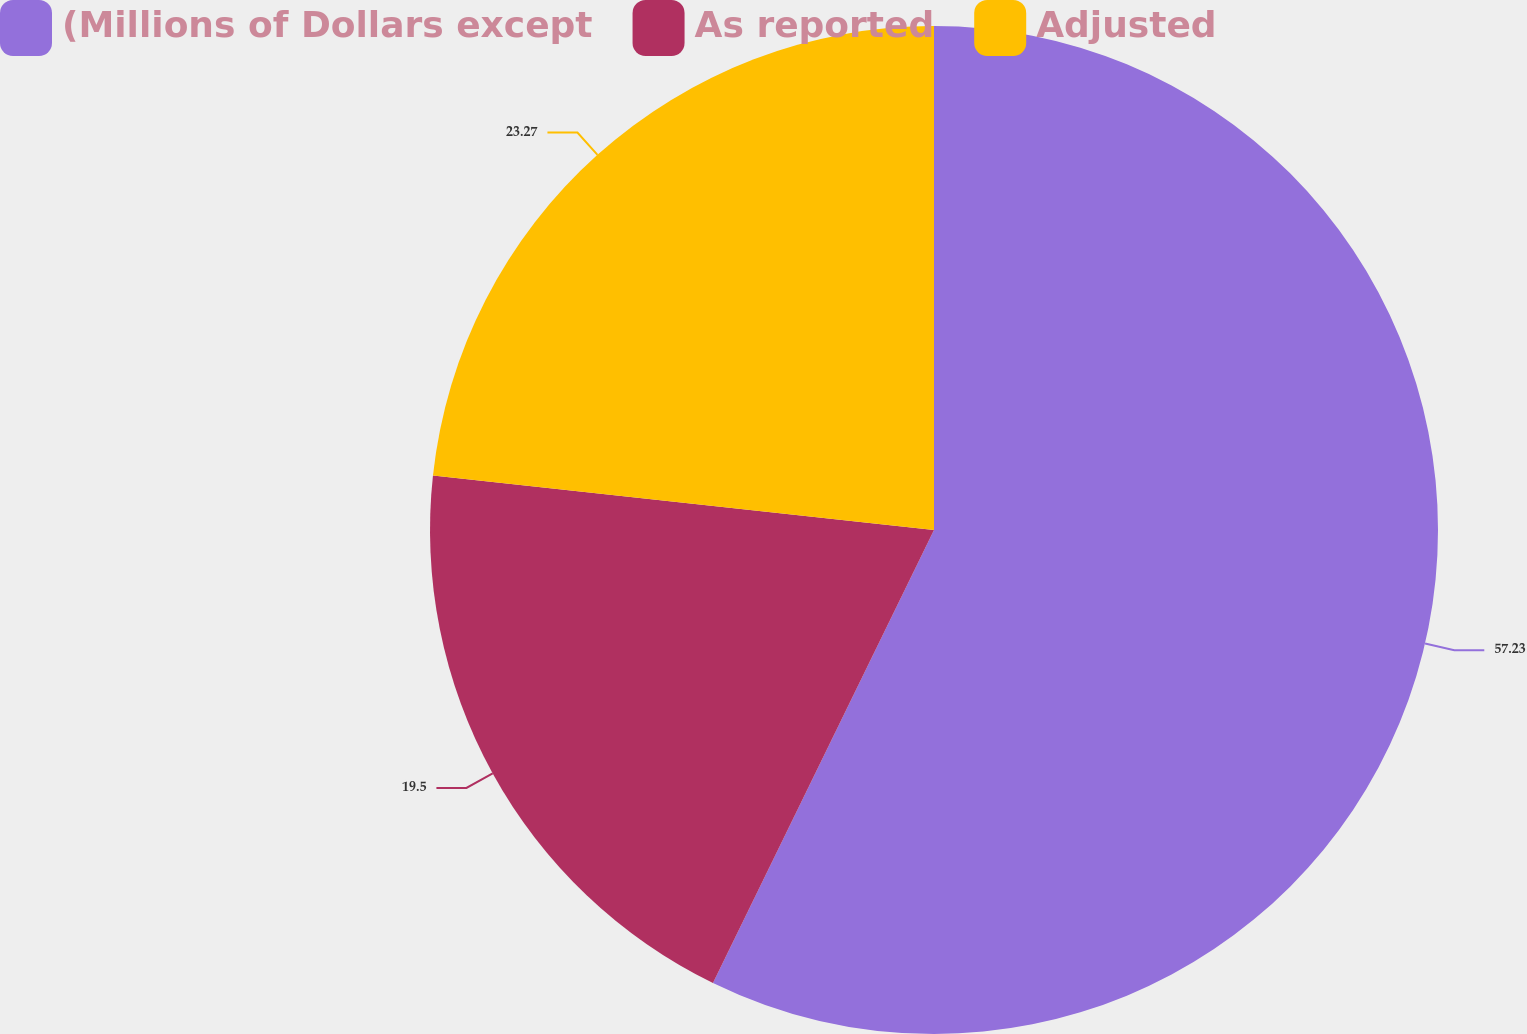<chart> <loc_0><loc_0><loc_500><loc_500><pie_chart><fcel>(Millions of Dollars except<fcel>As reported<fcel>Adjusted<nl><fcel>57.22%<fcel>19.5%<fcel>23.27%<nl></chart> 